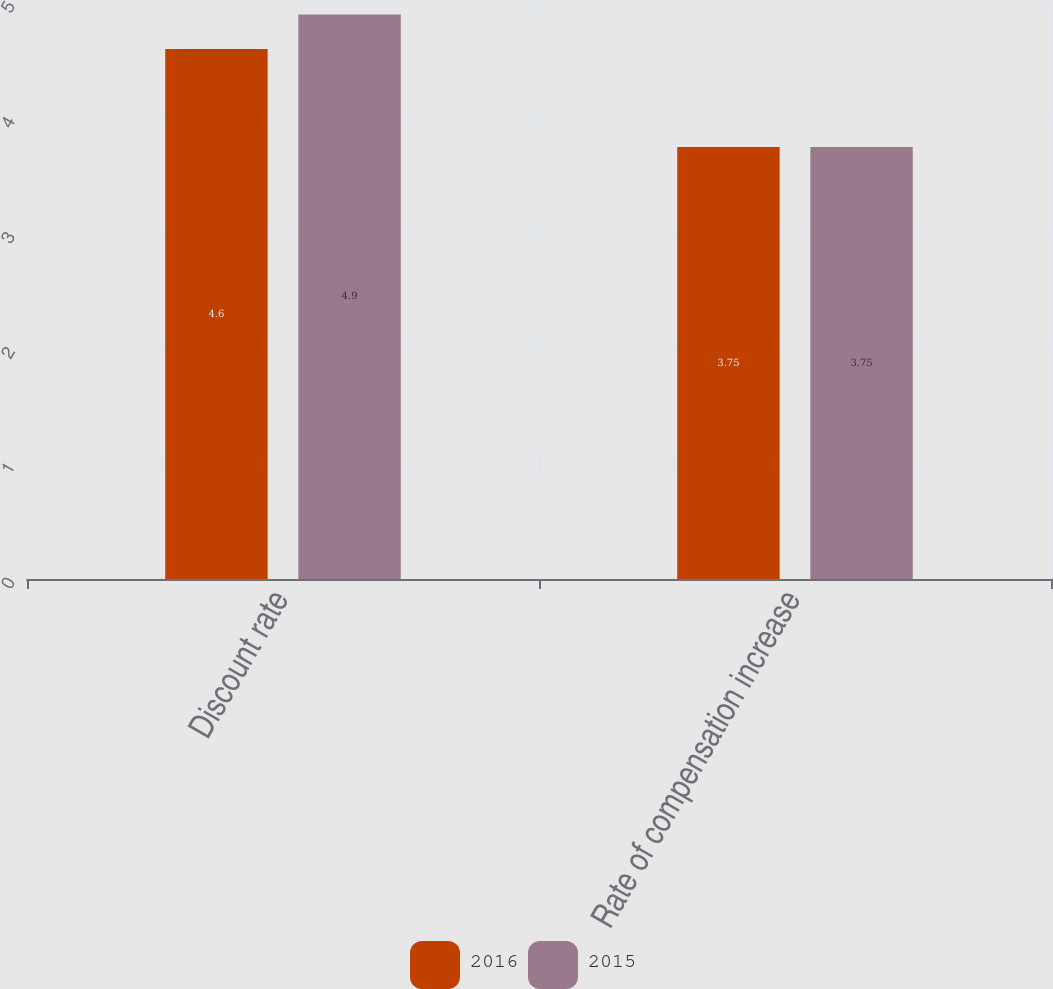Convert chart to OTSL. <chart><loc_0><loc_0><loc_500><loc_500><stacked_bar_chart><ecel><fcel>Discount rate<fcel>Rate of compensation increase<nl><fcel>2016<fcel>4.6<fcel>3.75<nl><fcel>2015<fcel>4.9<fcel>3.75<nl></chart> 